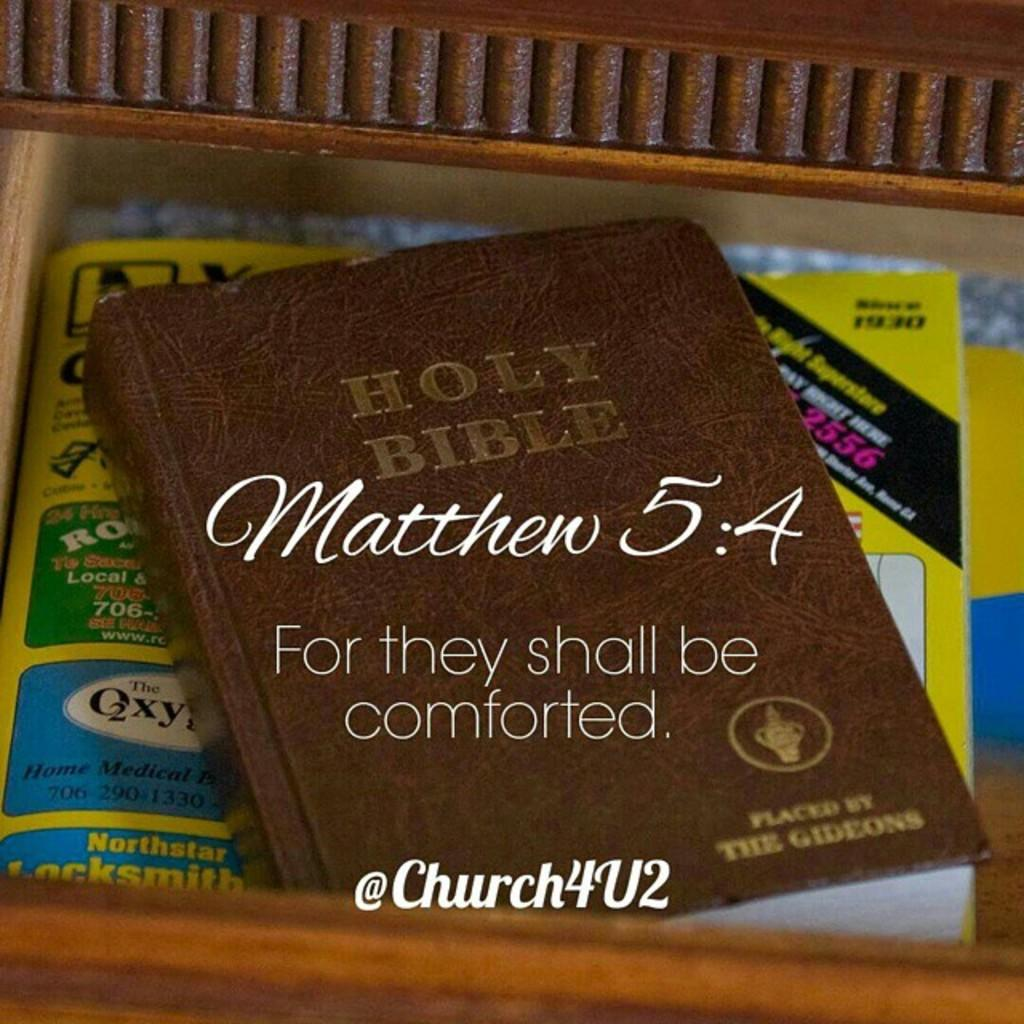<image>
Summarize the visual content of the image. A brown Holy Bible with the words Matthew 5:4 written on the front. 